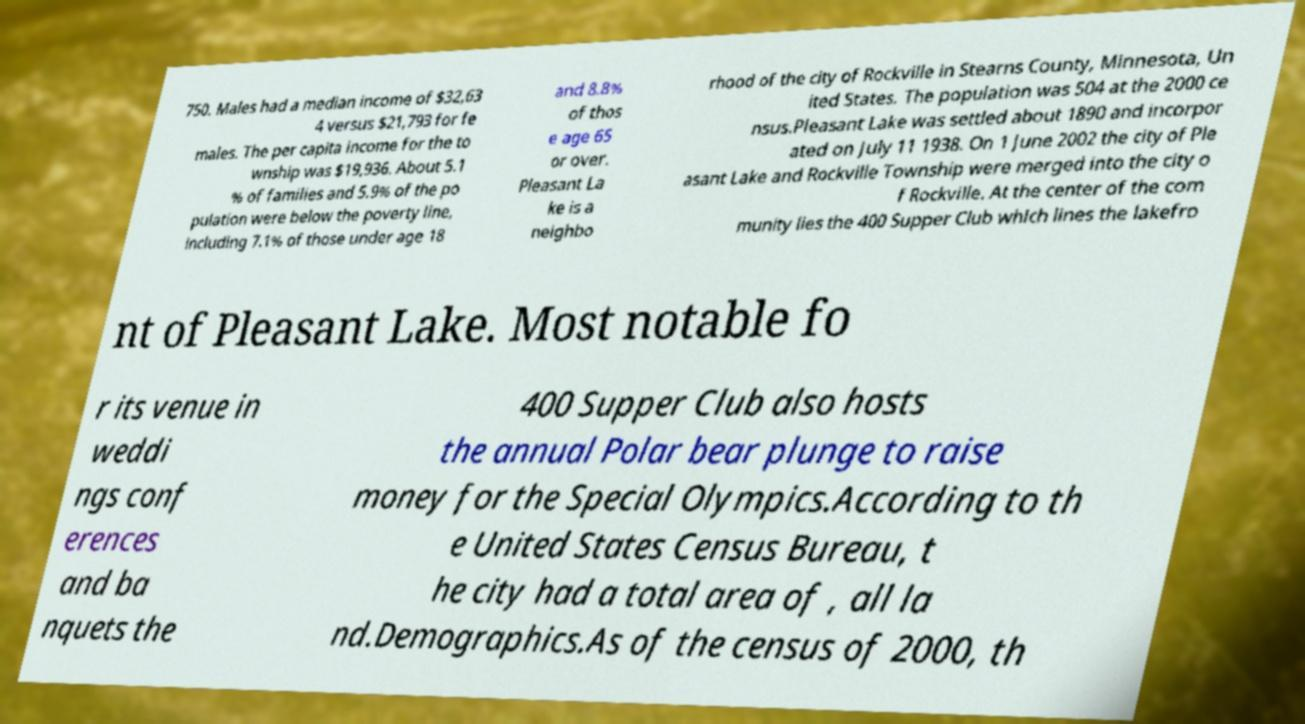Could you extract and type out the text from this image? 750. Males had a median income of $32,63 4 versus $21,793 for fe males. The per capita income for the to wnship was $19,936. About 5.1 % of families and 5.9% of the po pulation were below the poverty line, including 7.1% of those under age 18 and 8.8% of thos e age 65 or over. Pleasant La ke is a neighbo rhood of the city of Rockville in Stearns County, Minnesota, Un ited States. The population was 504 at the 2000 ce nsus.Pleasant Lake was settled about 1890 and incorpor ated on July 11 1938. On 1 June 2002 the city of Ple asant Lake and Rockville Township were merged into the city o f Rockville. At the center of the com munity lies the 400 Supper Club which lines the lakefro nt of Pleasant Lake. Most notable fo r its venue in weddi ngs conf erences and ba nquets the 400 Supper Club also hosts the annual Polar bear plunge to raise money for the Special Olympics.According to th e United States Census Bureau, t he city had a total area of , all la nd.Demographics.As of the census of 2000, th 